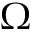Convert formula to latex. <formula><loc_0><loc_0><loc_500><loc_500>\Omega</formula> 